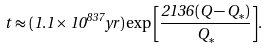Convert formula to latex. <formula><loc_0><loc_0><loc_500><loc_500>t \approx ( 1 . 1 \times 1 0 ^ { 8 3 7 } y r ) \exp { \left [ { \frac { 2 1 3 6 ( Q - Q _ { * } ) } { Q _ { * } } } \right ] } .</formula> 